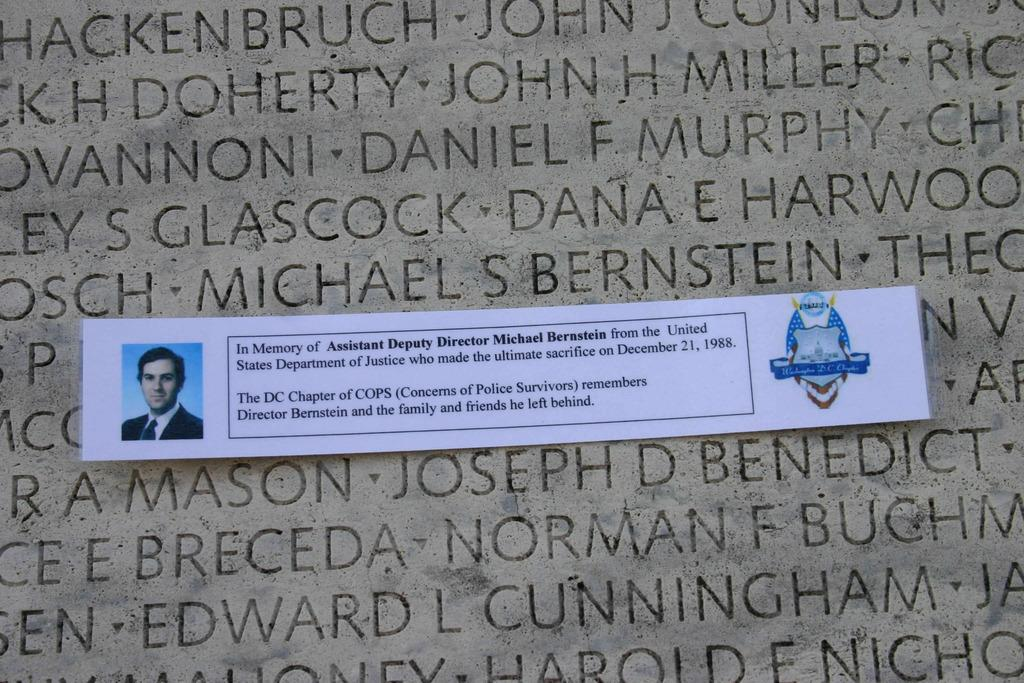What is present in the image? There is a paper in the image. What is depicted on the paper? The paper contains an image of a man. What flavor of coal is being used by the cow in the image? There is no cow or coal present in the image; it only contains a paper with an image of a man. 